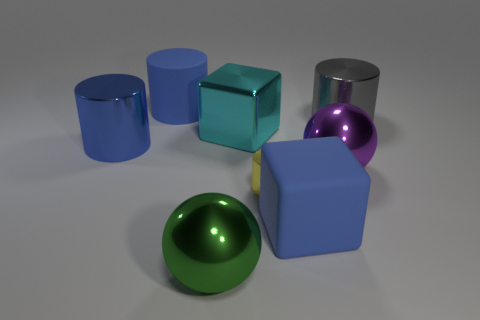The metal object that is the same color as the rubber cylinder is what size?
Offer a terse response. Large. Is the material of the large purple ball the same as the blue block?
Keep it short and to the point. No. What number of purple things are large balls or large matte cylinders?
Give a very brief answer. 1. There is a green shiny ball; how many cylinders are on the right side of it?
Give a very brief answer. 2. Is the number of yellow shiny cylinders greater than the number of large cylinders?
Your answer should be very brief. No. There is a large matte thing that is behind the blue matte object that is to the right of the big green object; what is its shape?
Make the answer very short. Cylinder. Do the small metal object and the rubber cube have the same color?
Give a very brief answer. No. Are there more blue rubber objects that are on the left side of the tiny yellow metallic cylinder than big cyan metallic balls?
Your answer should be compact. Yes. How many big things are right of the big rubber object in front of the big cyan metal cube?
Your answer should be compact. 2. Is the material of the block to the left of the yellow cylinder the same as the thing that is behind the large gray thing?
Keep it short and to the point. No. 